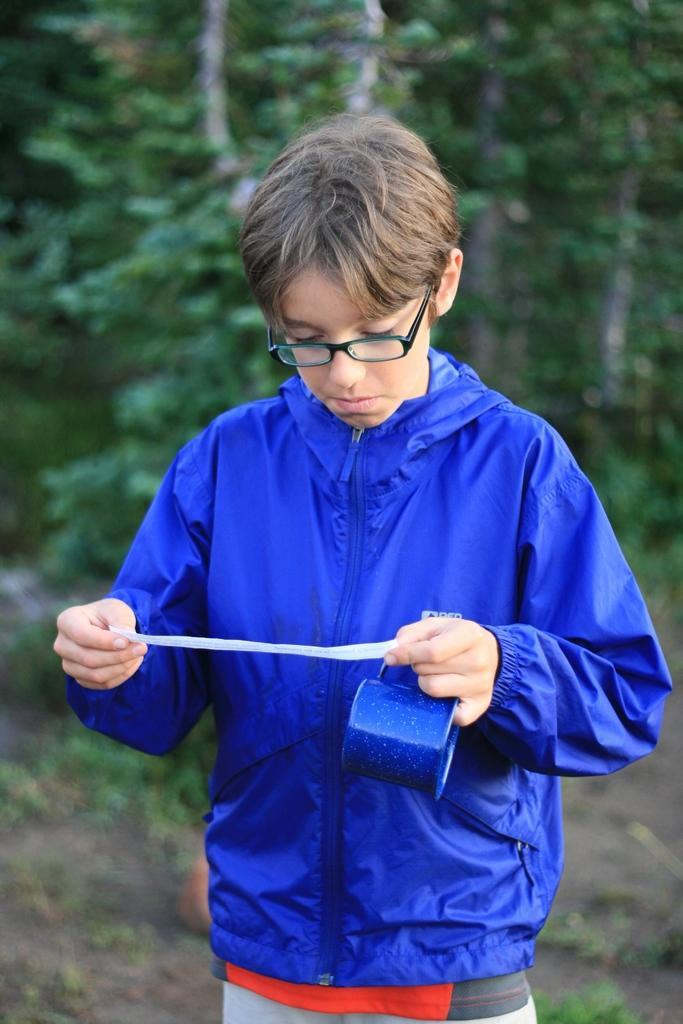What is the main subject of the image? There is a person standing in the image. What is the person holding in the image? The person is holding objects. Can you describe the person's clothing in the image? The person is wearing a blue jacket. What can be seen in the background of the image? There are trees in the background of the image. What is the color of the trees in the image? The trees are green in color. How many pigs are visible in the image? There are no pigs present in the image. What type of footwear is the person wearing in the image? The provided facts do not mention the person's footwear. 